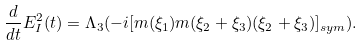<formula> <loc_0><loc_0><loc_500><loc_500>\frac { d } { d t } E ^ { 2 } _ { I } ( t ) = \Lambda _ { 3 } ( - i [ m ( \xi _ { 1 } ) m ( \xi _ { 2 } + \xi _ { 3 } ) ( \xi _ { 2 } + \xi _ { 3 } ) ] _ { s y m } ) .</formula> 